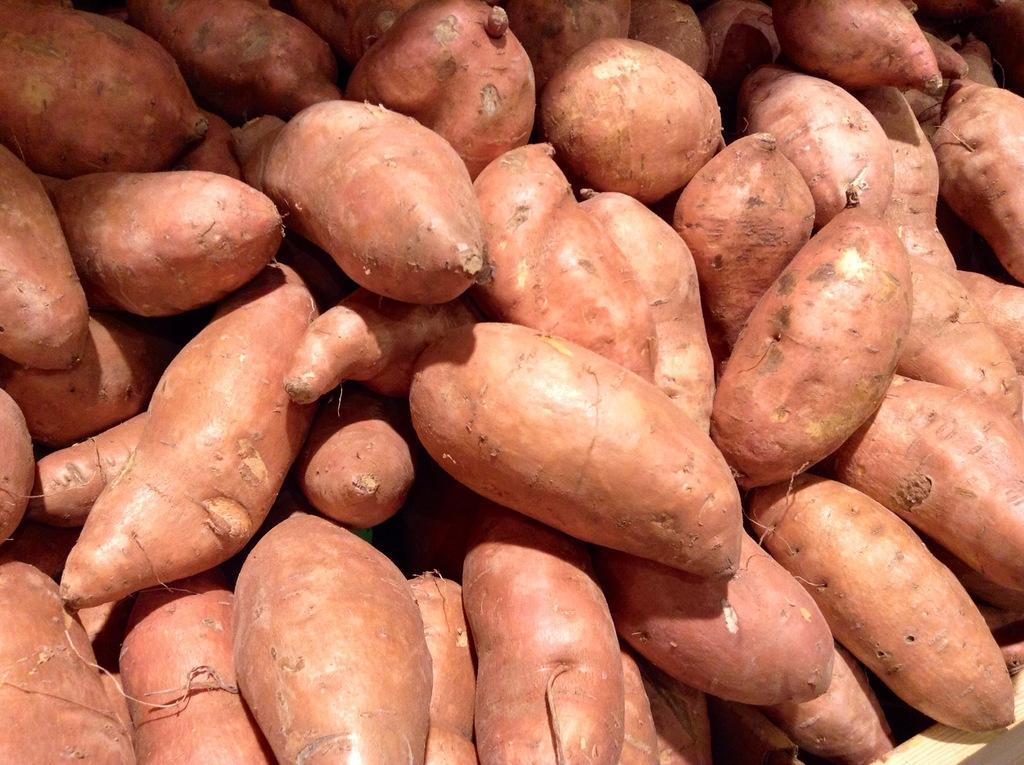Could you give a brief overview of what you see in this image? The picture consists of sweet potatoes. 